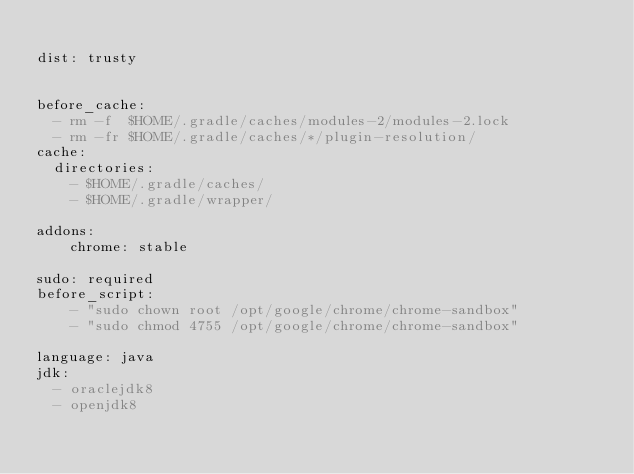Convert code to text. <code><loc_0><loc_0><loc_500><loc_500><_YAML_>
dist: trusty


before_cache:
  - rm -f  $HOME/.gradle/caches/modules-2/modules-2.lock
  - rm -fr $HOME/.gradle/caches/*/plugin-resolution/
cache:
  directories:
    - $HOME/.gradle/caches/
    - $HOME/.gradle/wrapper/

addons:
    chrome: stable

sudo: required
before_script:
    - "sudo chown root /opt/google/chrome/chrome-sandbox"
    - "sudo chmod 4755 /opt/google/chrome/chrome-sandbox"

language: java
jdk:
  - oraclejdk8
  - openjdk8
</code> 